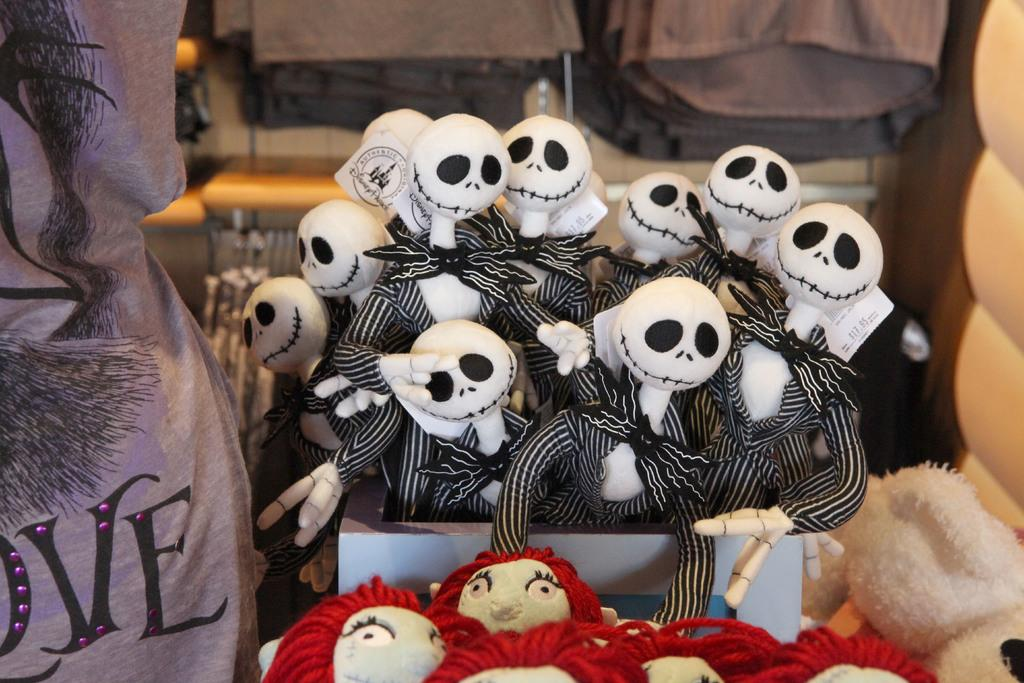What objects are inside the box in the image? There are toys in the box. Can you describe the background of the image? The background of the image is blurry. What type of cable is being advised to remain quiet in the image? There is no cable or advice present in the image; it only features a box of toys and a blurry background. 